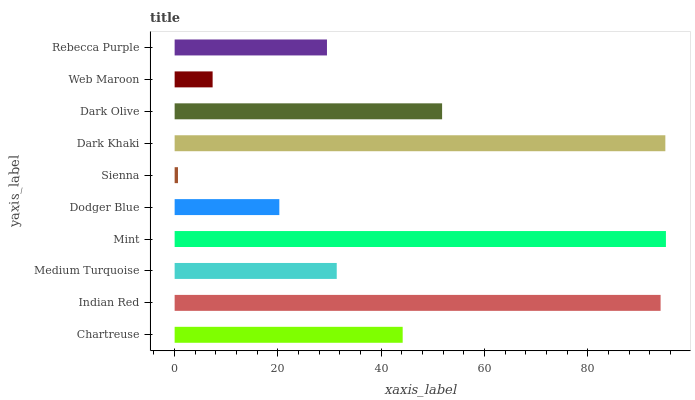Is Sienna the minimum?
Answer yes or no. Yes. Is Mint the maximum?
Answer yes or no. Yes. Is Indian Red the minimum?
Answer yes or no. No. Is Indian Red the maximum?
Answer yes or no. No. Is Indian Red greater than Chartreuse?
Answer yes or no. Yes. Is Chartreuse less than Indian Red?
Answer yes or no. Yes. Is Chartreuse greater than Indian Red?
Answer yes or no. No. Is Indian Red less than Chartreuse?
Answer yes or no. No. Is Chartreuse the high median?
Answer yes or no. Yes. Is Medium Turquoise the low median?
Answer yes or no. Yes. Is Web Maroon the high median?
Answer yes or no. No. Is Dodger Blue the low median?
Answer yes or no. No. 